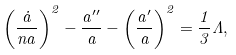Convert formula to latex. <formula><loc_0><loc_0><loc_500><loc_500>\left ( \frac { \dot { a } } { n a } \right ) ^ { 2 } - \frac { a ^ { \prime \prime } } { a } - \left ( \frac { a ^ { \prime } } { a } \right ) ^ { 2 } = \frac { 1 } { 3 } \Lambda ,</formula> 